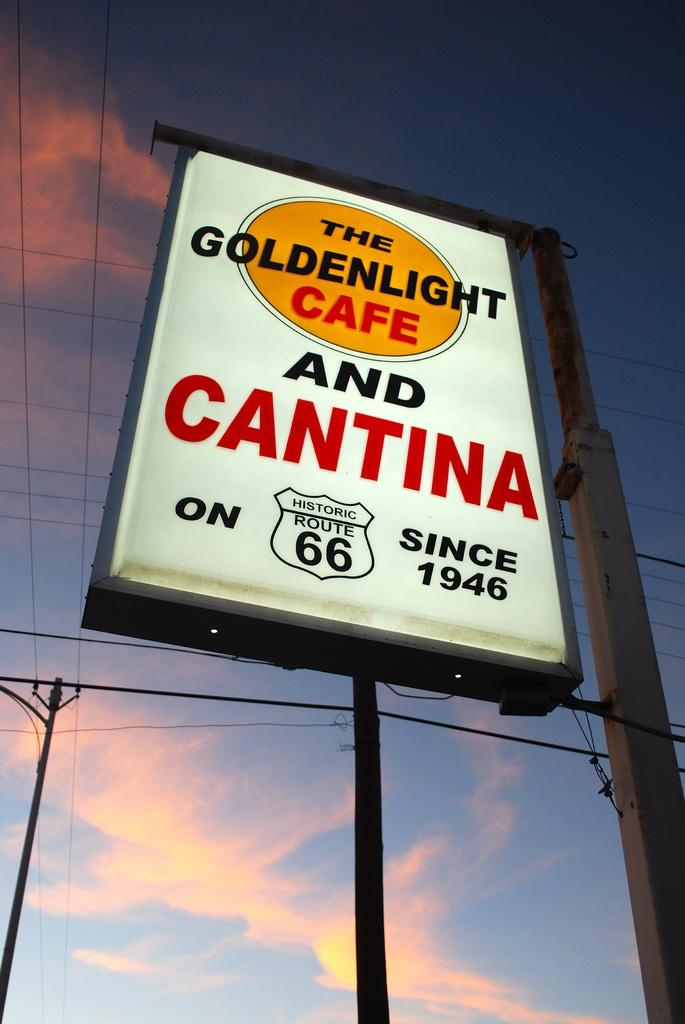What is on the board that is visible in the image? There is a board with text in the image. What is located beside the board? There is a pole beside the board. What can be seen in the background of the image? There is another pole with wires in the background of the image. What is visible at the top of the image? The sky is visible at the top of the image. What type of trousers is the crow wearing in the image? There is no crow or trousers present in the image. What time of day is depicted in the image? The time of day cannot be determined from the image, as there are no specific time-related details provided. 